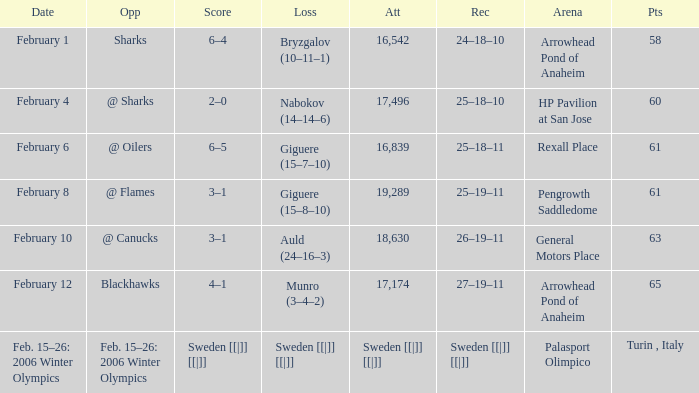What is the record when the score was 2–0? 25–18–10. 